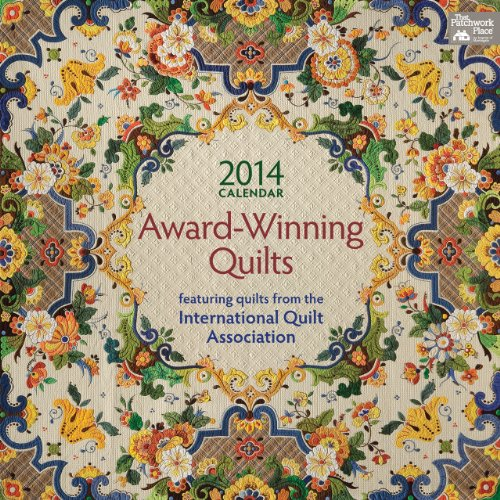Can you tell which types of quilt patterns are featured in this calendar? The calendar features a variety of quilt patterns including traditional patchworks, intricate appliques, and modern geometric designs, each showcasing remarkable craftsmanship and creativity. 